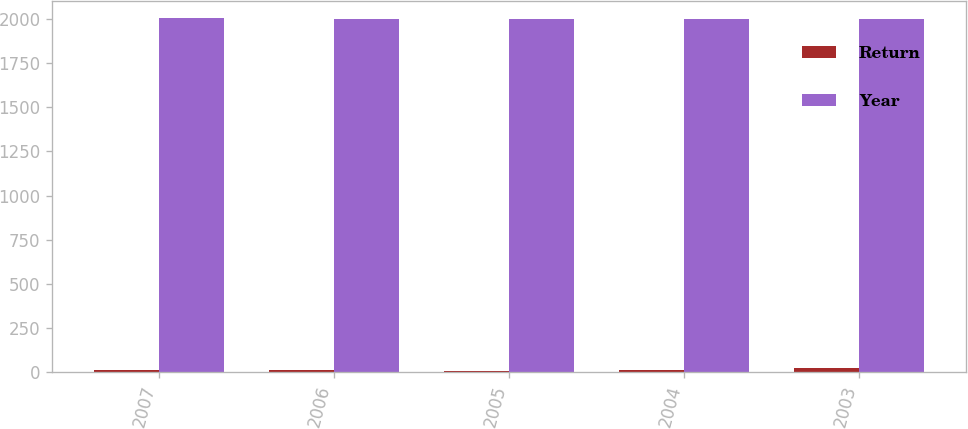Convert chart to OTSL. <chart><loc_0><loc_0><loc_500><loc_500><stacked_bar_chart><ecel><fcel>2007<fcel>2006<fcel>2005<fcel>2004<fcel>2003<nl><fcel>Return<fcel>10.3<fcel>14.9<fcel>9.8<fcel>12.6<fcel>25<nl><fcel>Year<fcel>2002<fcel>2001<fcel>2000<fcel>1999<fcel>1998<nl></chart> 